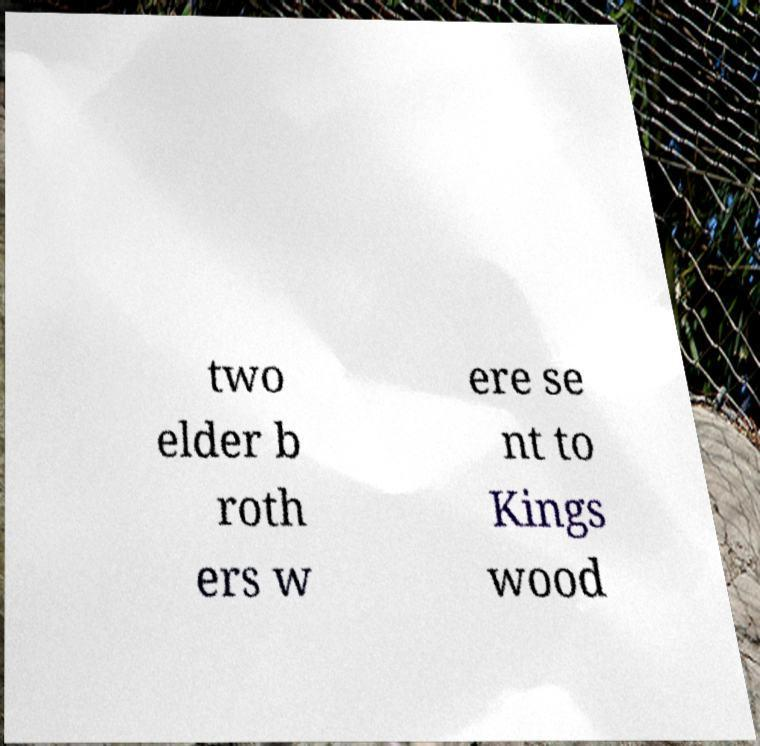Please read and relay the text visible in this image. What does it say? two elder b roth ers w ere se nt to Kings wood 